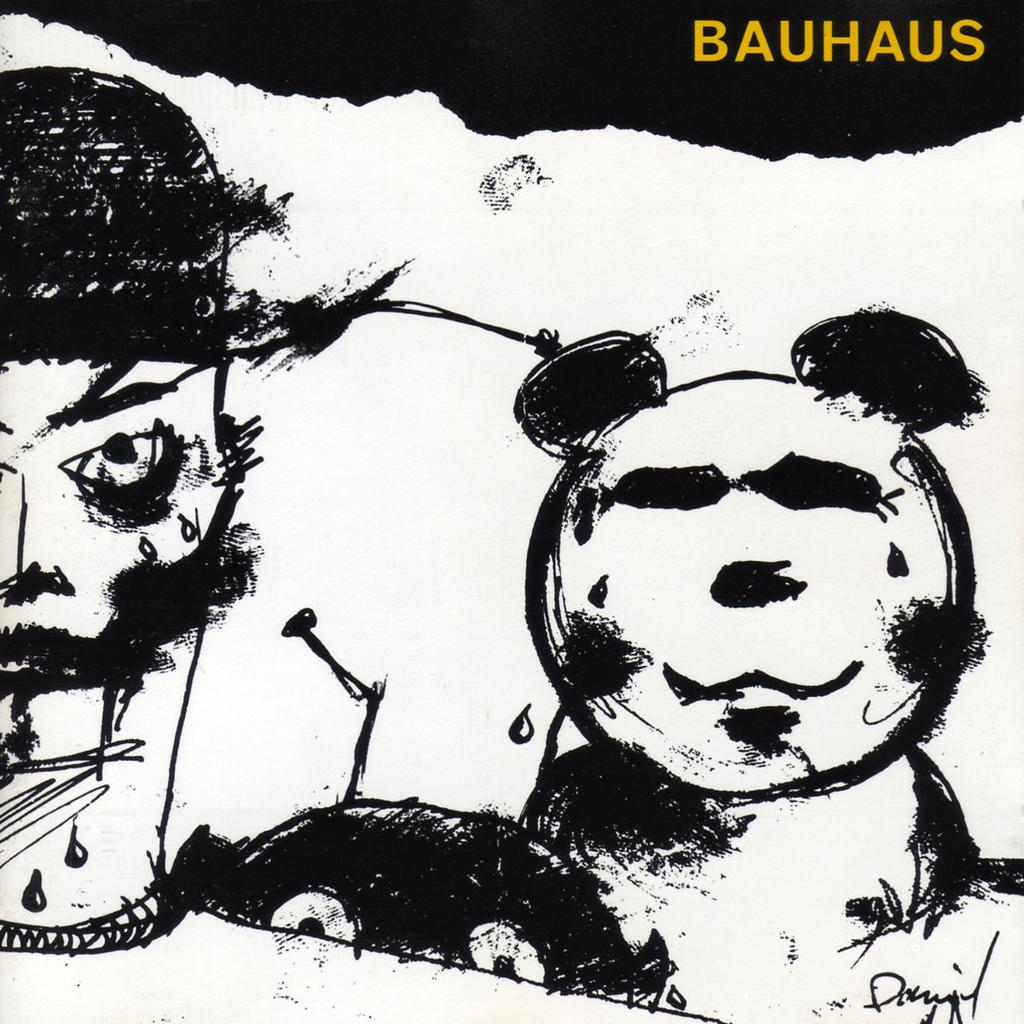What is the main subject of the image? The main subject of the image is a painting. Can you describe any additional elements in the image? Yes, there is text in the image. What type of trousers are being worn by the person in the painting? There is no person depicted in the painting, and therefore no trousers can be observed. What drug is being advertised in the text of the image? There is no text advertising any drug in the image. 